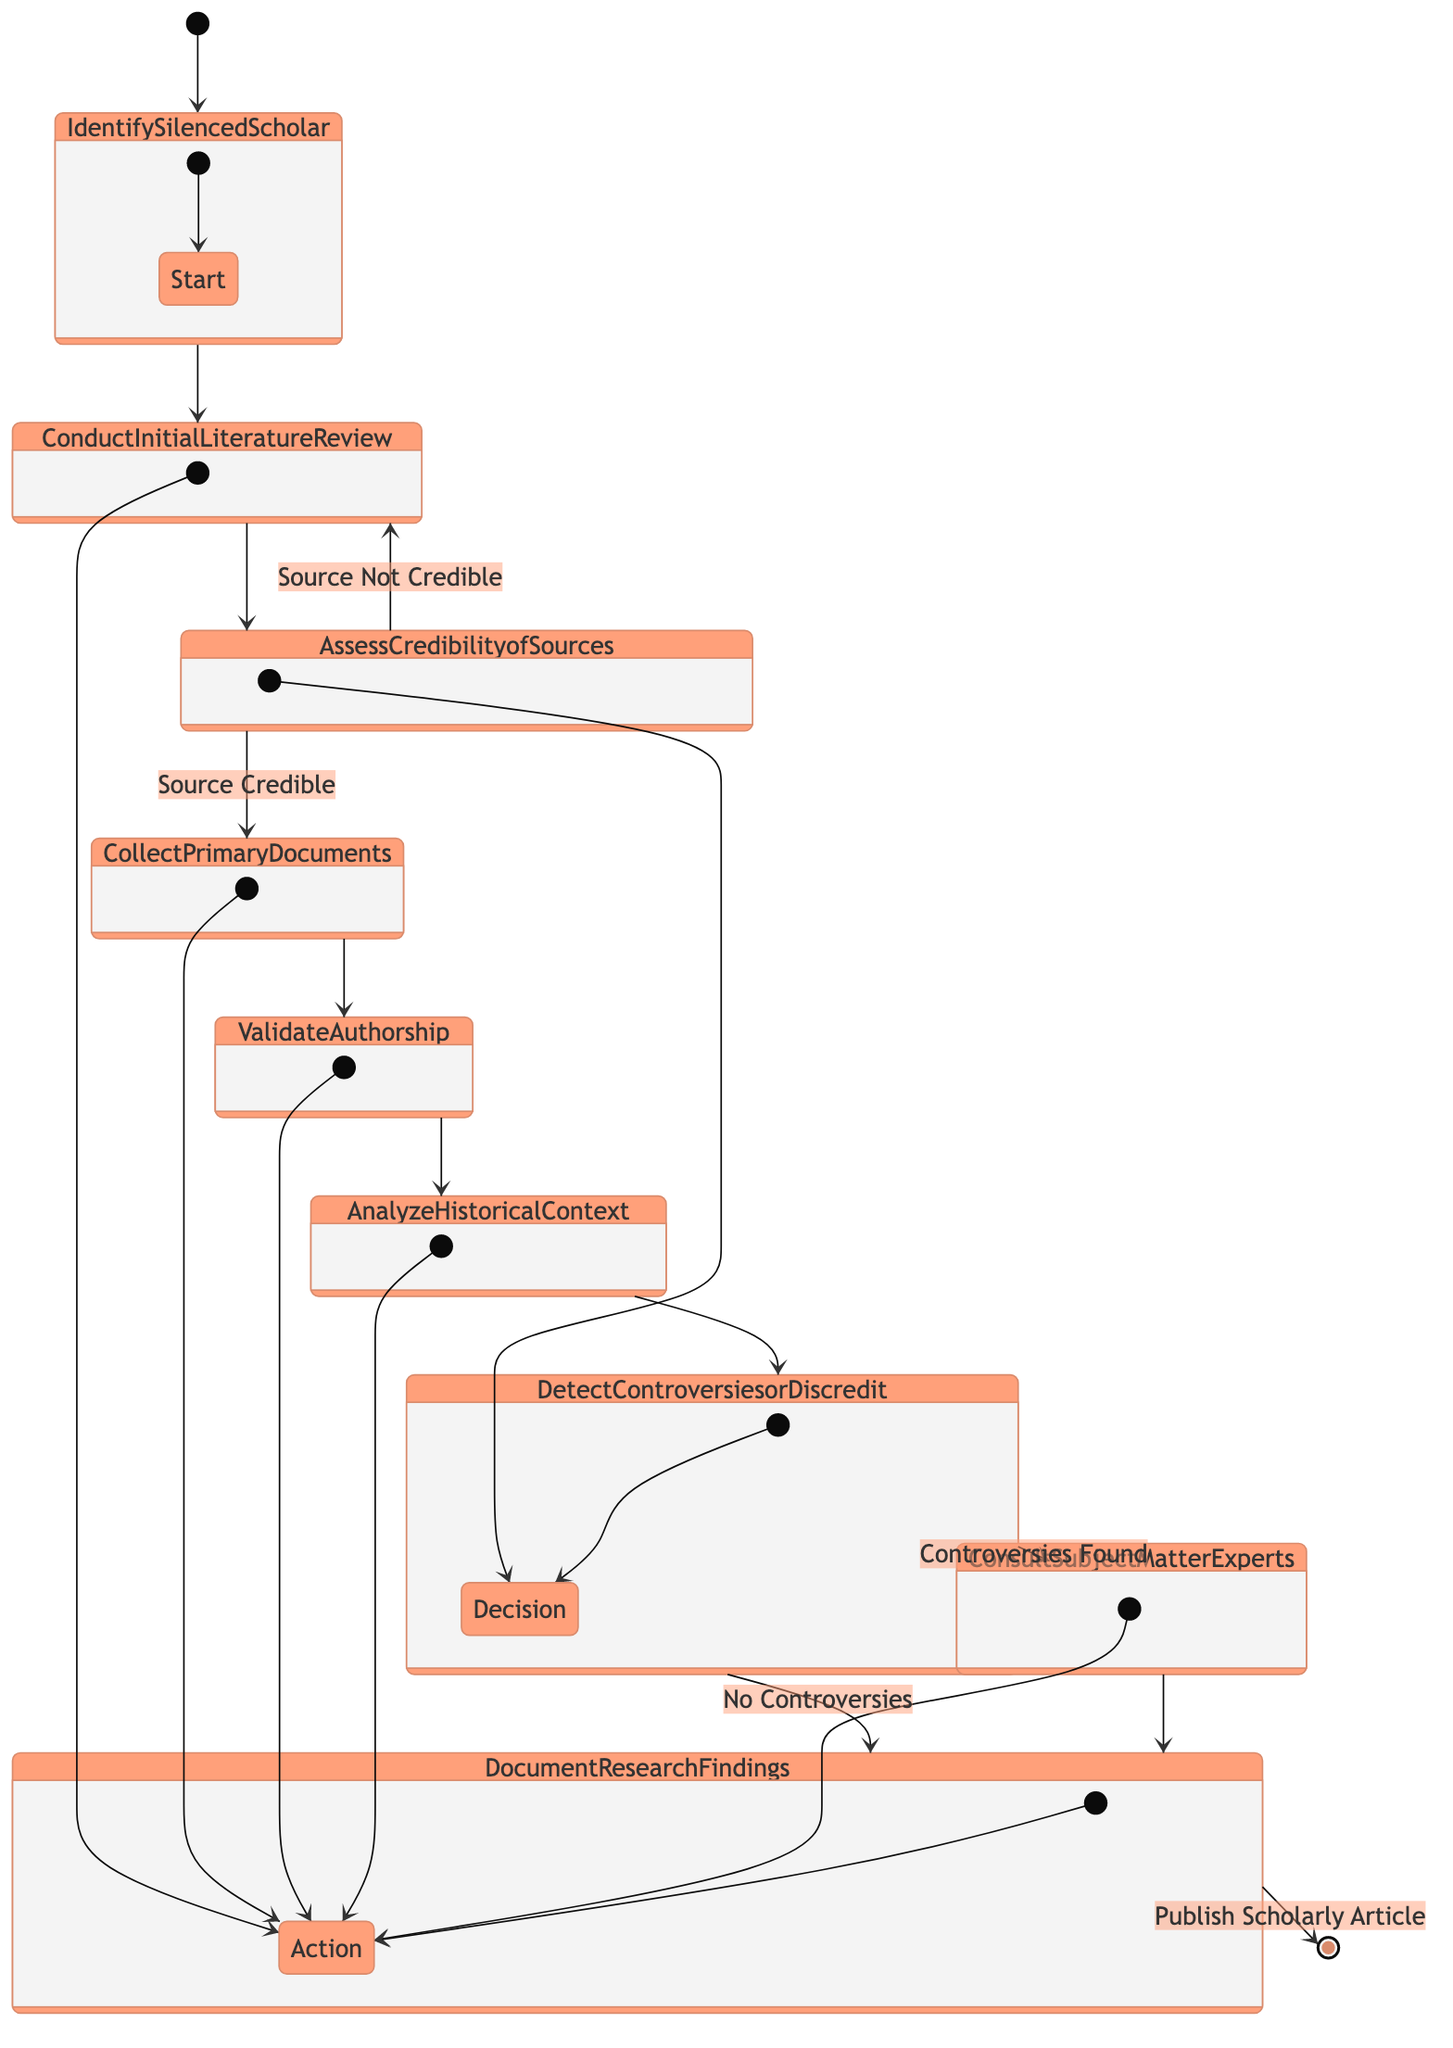What is the first action in the diagram? The first action in the diagram is represented by the node following the start node, which is "Identify Silenced Scholar."
Answer: Identify Silenced Scholar How many actions are there in the process? By counting the nodes categorized as actions, we find there are six distinct actions: "Conduct Initial Literature Review," "Collect Primary Documents," "Validate Authorship," "Analyze Historical Context," "Consult Subject Matter Experts," and "Document Research Findings."
Answer: 6 What happens if the sources assessed are not credible? If the sources assessed are not credible, the flow will revert back to "Conduct Initial Literature Review" as represented by that edge in the diagram.
Answer: Conduct Initial Literature Review At which point do we verify the authorship? The verification of authorship occurs after collecting the primary documents, as indicated by the edge leading from "Collect Primary Documents" to "Validate Authorship."
Answer: Validate Authorship What is the final outcome after documenting the research findings? The final outcome after documenting the research findings is to "Publish Scholarly Article," denoting the completion of the research process.
Answer: Publish Scholarly Article What decision must be made regarding controversies? The decision regarding controversies is captured in the "Detect Controversies or Discredit" node, where the researcher assesses if there are any controversies present.
Answer: Detect Controversies or Discredit What action follows if controversies are found? If controversies are found, the next action to be taken is to "Consult Subject Matter Experts," continuing the research flow accordingly.
Answer: Consult Subject Matter Experts What happens if no controversies are detected? If no controversies are detected, the process proceeds directly to "Document Research Findings" from the decision node, indicating an absence of issues.
Answer: Document Research Findings 